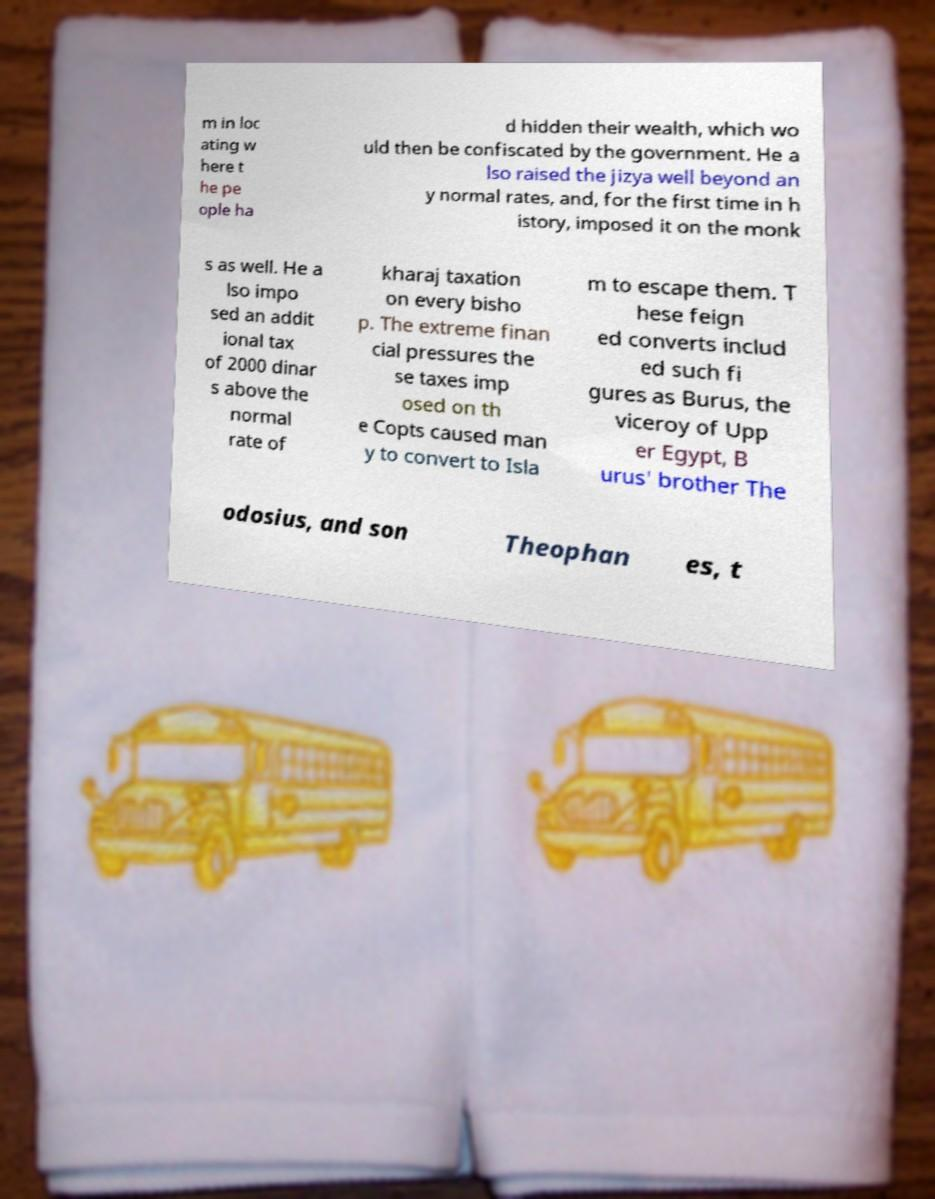Could you assist in decoding the text presented in this image and type it out clearly? m in loc ating w here t he pe ople ha d hidden their wealth, which wo uld then be confiscated by the government. He a lso raised the jizya well beyond an y normal rates, and, for the first time in h istory, imposed it on the monk s as well. He a lso impo sed an addit ional tax of 2000 dinar s above the normal rate of kharaj taxation on every bisho p. The extreme finan cial pressures the se taxes imp osed on th e Copts caused man y to convert to Isla m to escape them. T hese feign ed converts includ ed such fi gures as Burus, the viceroy of Upp er Egypt, B urus' brother The odosius, and son Theophan es, t 